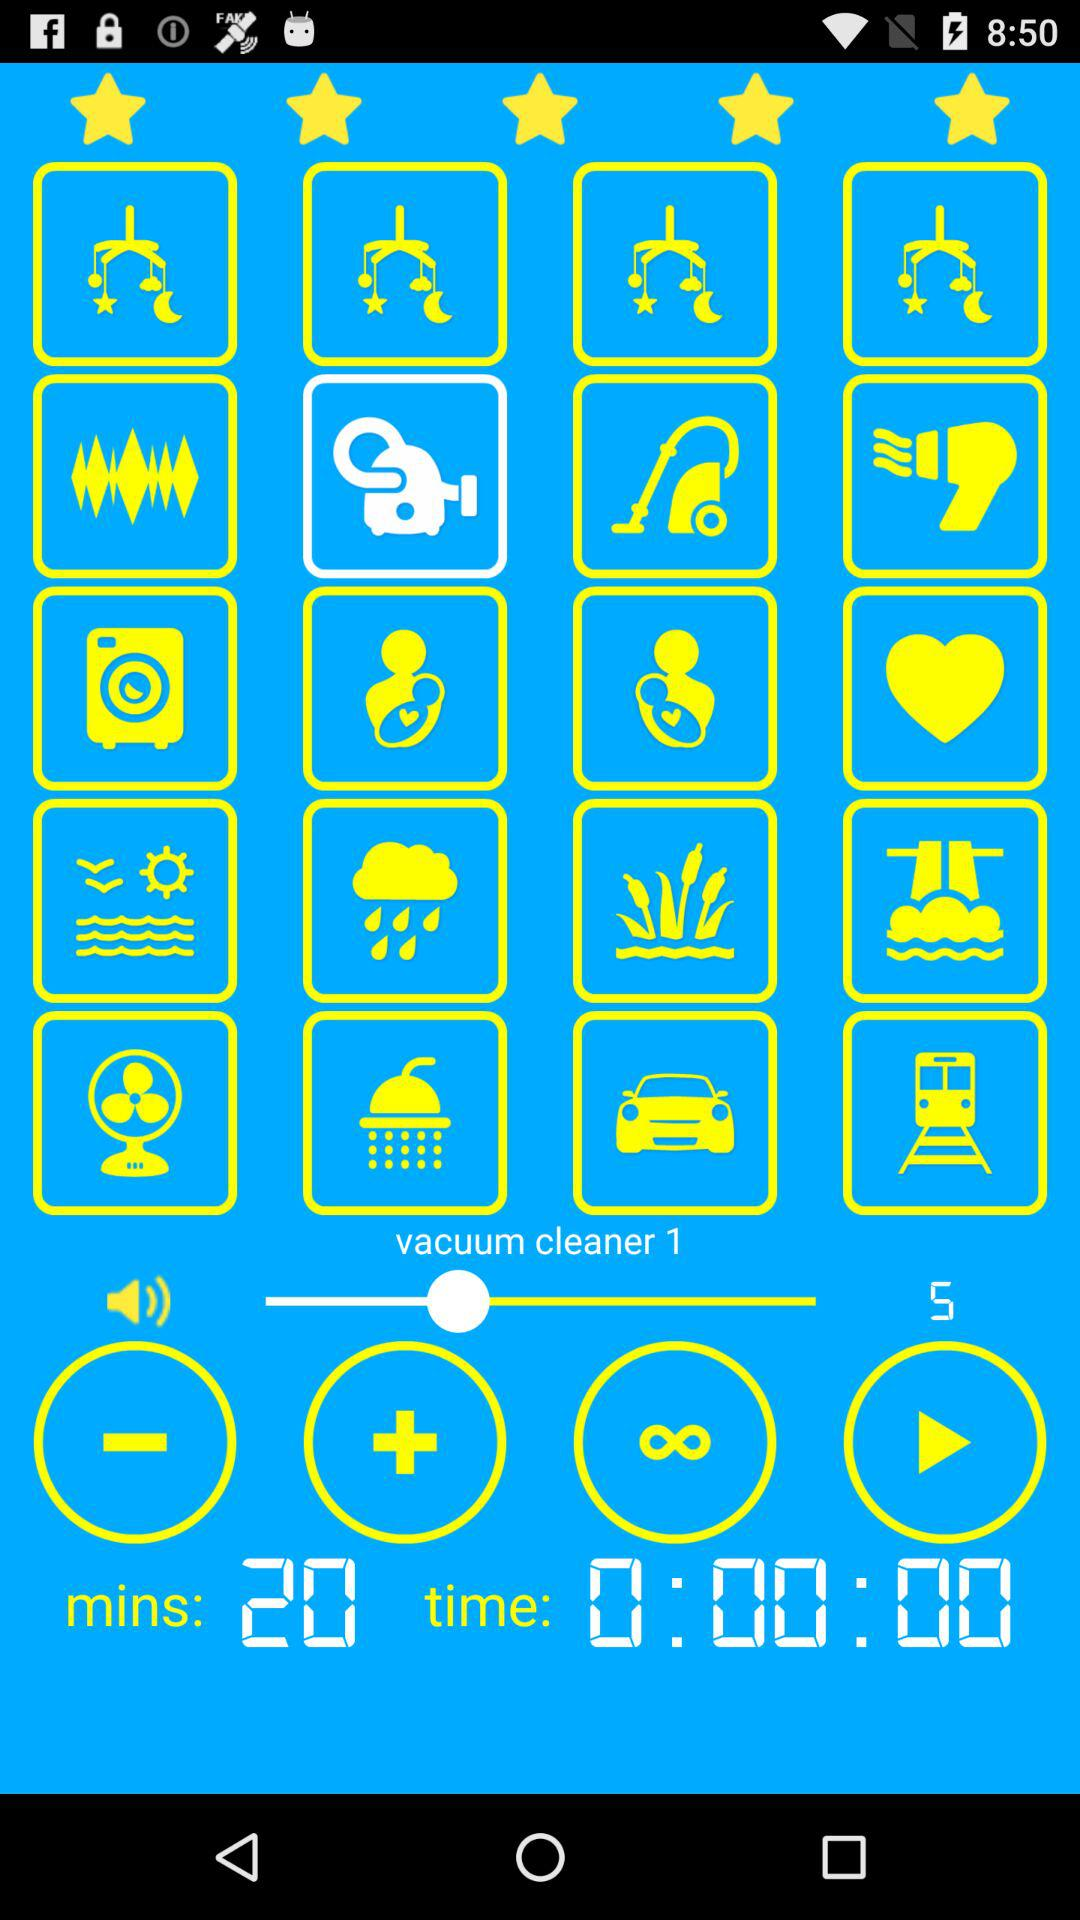How many minutes are mentioned? There are 20 minutes mentioned. 